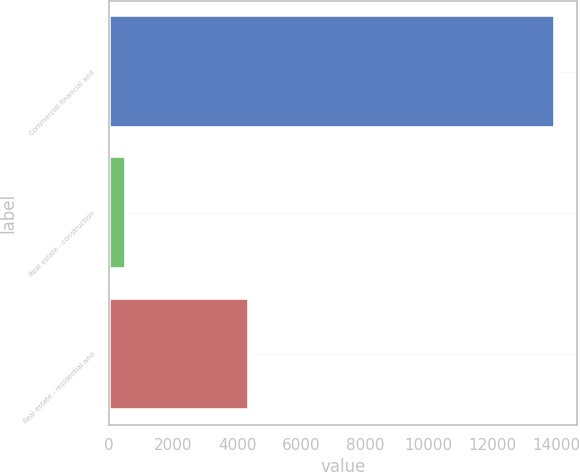Convert chart to OTSL. <chart><loc_0><loc_0><loc_500><loc_500><bar_chart><fcel>Commercial financial and<fcel>Real estate - construction<fcel>Real estate - residential and<nl><fcel>13957<fcel>534<fcel>4365<nl></chart> 